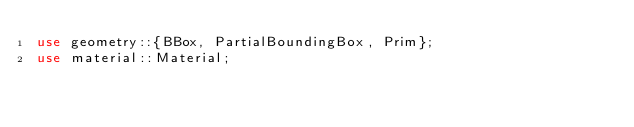<code> <loc_0><loc_0><loc_500><loc_500><_Rust_>use geometry::{BBox, PartialBoundingBox, Prim};
use material::Material;</code> 